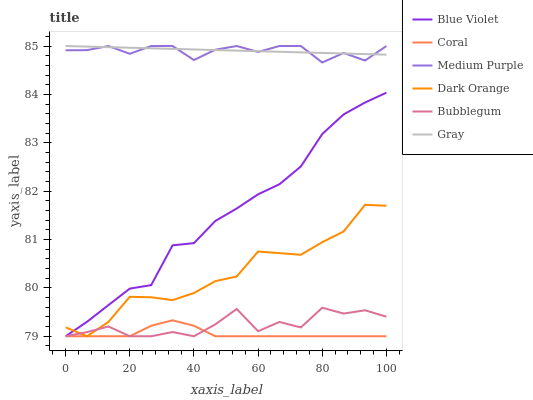Does Coral have the minimum area under the curve?
Answer yes or no. Yes. Does Gray have the maximum area under the curve?
Answer yes or no. Yes. Does Gray have the minimum area under the curve?
Answer yes or no. No. Does Coral have the maximum area under the curve?
Answer yes or no. No. Is Gray the smoothest?
Answer yes or no. Yes. Is Bubblegum the roughest?
Answer yes or no. Yes. Is Coral the smoothest?
Answer yes or no. No. Is Coral the roughest?
Answer yes or no. No. Does Dark Orange have the lowest value?
Answer yes or no. Yes. Does Gray have the lowest value?
Answer yes or no. No. Does Medium Purple have the highest value?
Answer yes or no. Yes. Does Coral have the highest value?
Answer yes or no. No. Is Blue Violet less than Gray?
Answer yes or no. Yes. Is Gray greater than Blue Violet?
Answer yes or no. Yes. Does Dark Orange intersect Coral?
Answer yes or no. Yes. Is Dark Orange less than Coral?
Answer yes or no. No. Is Dark Orange greater than Coral?
Answer yes or no. No. Does Blue Violet intersect Gray?
Answer yes or no. No. 